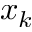Convert formula to latex. <formula><loc_0><loc_0><loc_500><loc_500>x _ { k }</formula> 